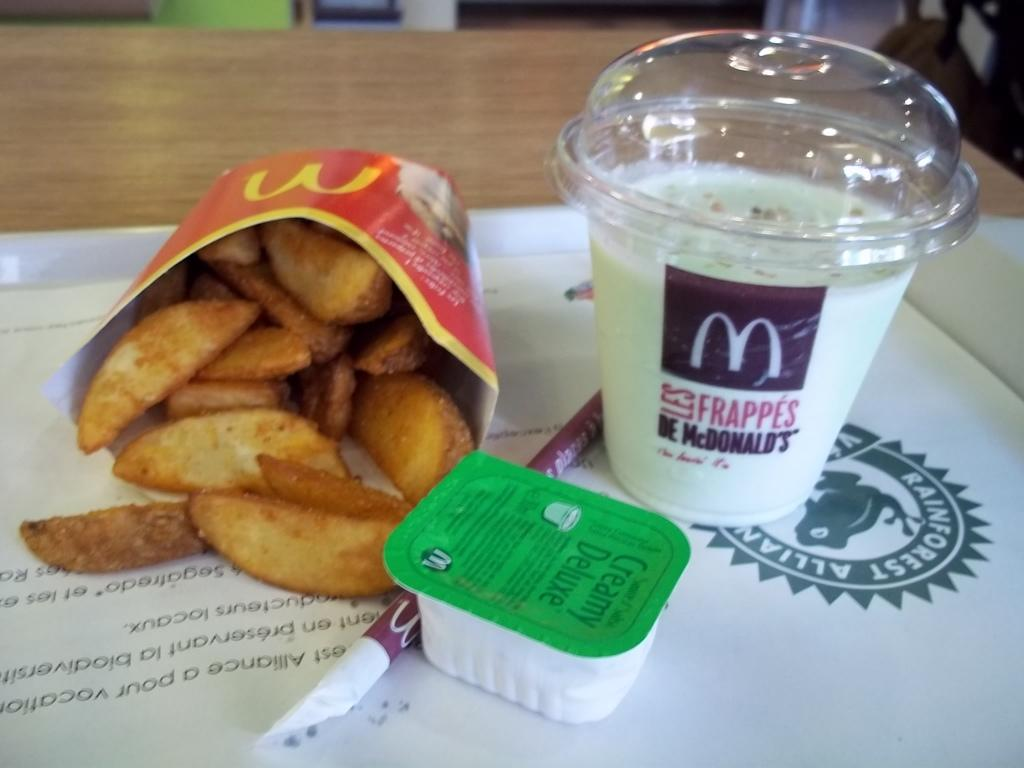What type of furniture is present in the image? There is a table in the image. What beverage can be seen in the image? There is a milkshake in the image. What type of snack is visible in the image? It appears there are chips in the image. What is used to drink the milkshake? There is a straw in the image. What is the small container in the image used for? There is a small cream box in the image. Can you tell me how many cacti are on the table in the image? There are no cacti present in the image; it only features a table, milkshake, chips, straw, and a small cream box. What is the table talking about in the image? Tables do not talk; they are inanimate objects. 